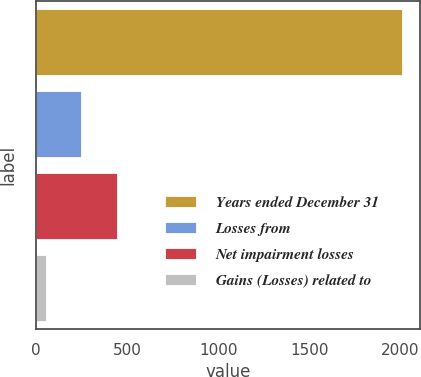<chart> <loc_0><loc_0><loc_500><loc_500><bar_chart><fcel>Years ended December 31<fcel>Losses from<fcel>Net impairment losses<fcel>Gains (Losses) related to<nl><fcel>2008<fcel>249.4<fcel>444.8<fcel>54<nl></chart> 